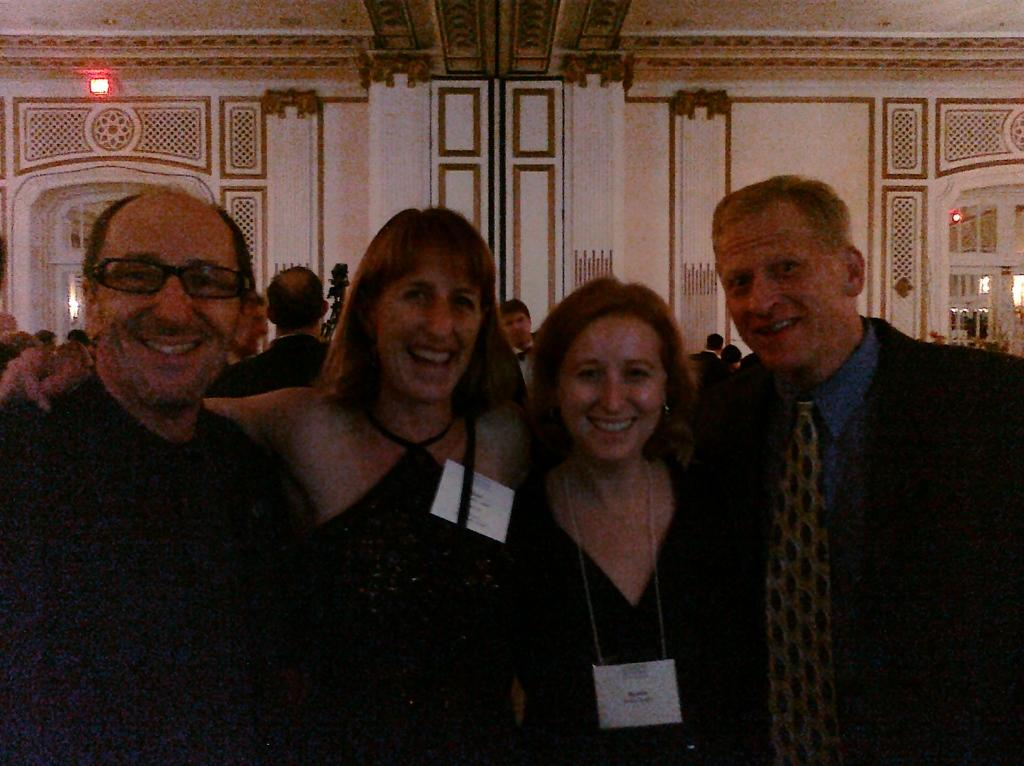How many people are in the image? There are two women and two men in the image. What are the people in the image doing? They are posing for a photograph. Can you describe the background of the image? There are people and a wall in the background of the image. What features can be seen on the wall? There are doors in the wall. What type of metal can be seen in the image? There is no metal present in the image. How do the people in the image express their anger? The image does not show any expressions of anger; the people are posing for a photograph. 